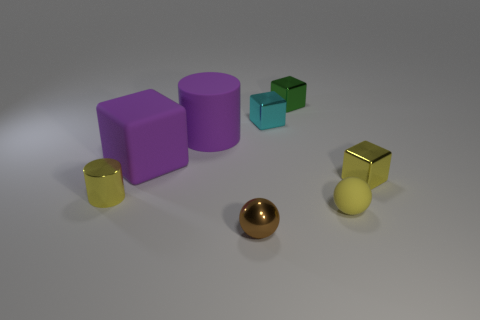Subtract all metal cubes. How many cubes are left? 1 Subtract 2 cubes. How many cubes are left? 2 Add 1 small objects. How many objects exist? 9 Subtract all brown cubes. Subtract all cyan spheres. How many cubes are left? 4 Subtract all cylinders. How many objects are left? 6 Add 8 large green shiny cubes. How many large green shiny cubes exist? 8 Subtract 0 brown cubes. How many objects are left? 8 Subtract all small blocks. Subtract all purple things. How many objects are left? 3 Add 8 matte cylinders. How many matte cylinders are left? 9 